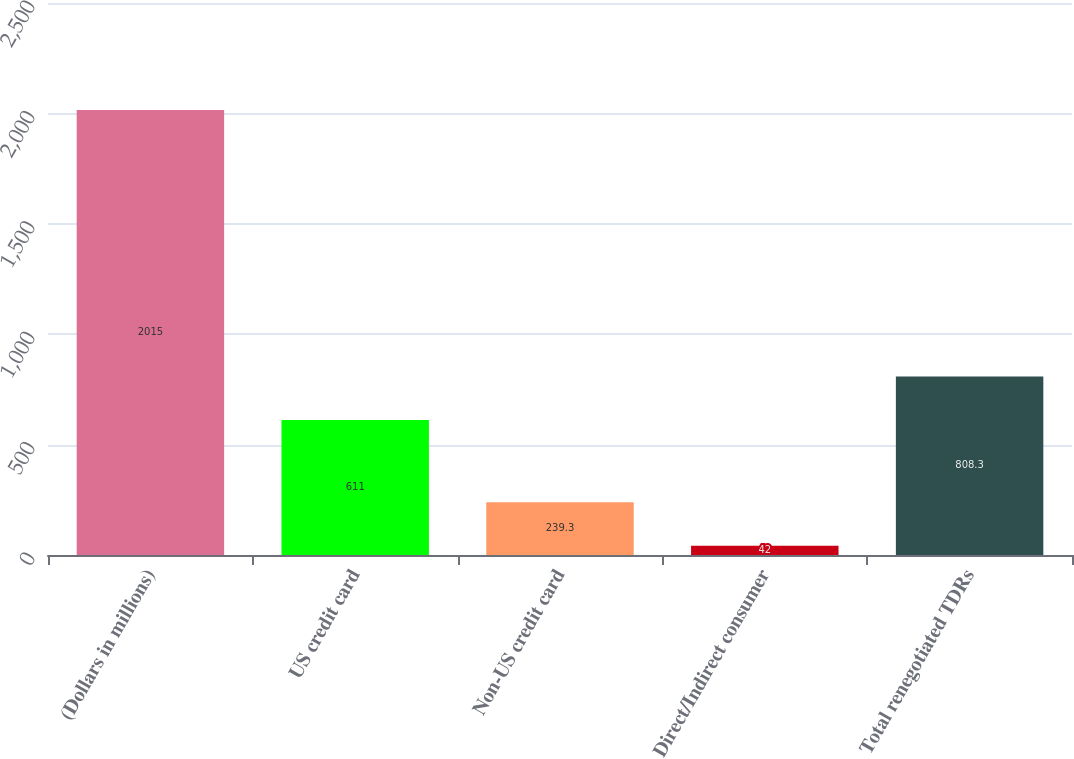<chart> <loc_0><loc_0><loc_500><loc_500><bar_chart><fcel>(Dollars in millions)<fcel>US credit card<fcel>Non-US credit card<fcel>Direct/Indirect consumer<fcel>Total renegotiated TDRs<nl><fcel>2015<fcel>611<fcel>239.3<fcel>42<fcel>808.3<nl></chart> 